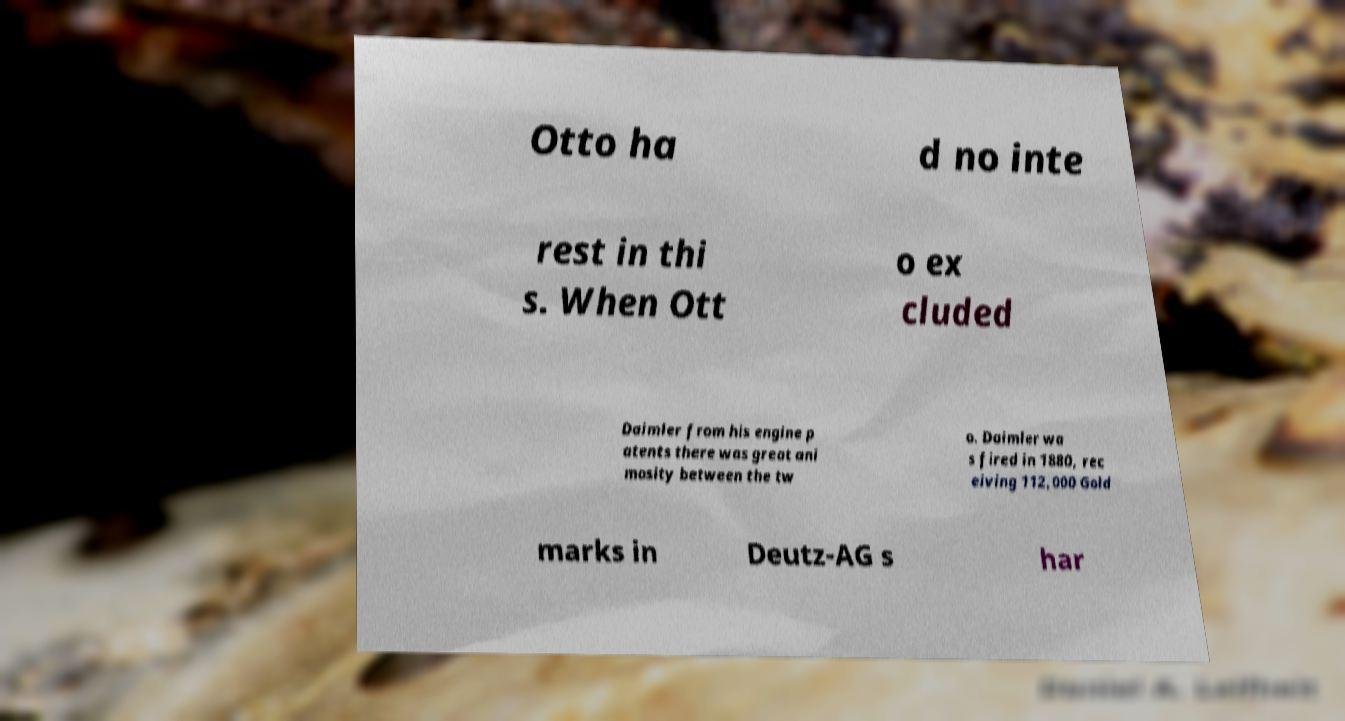Please identify and transcribe the text found in this image. Otto ha d no inte rest in thi s. When Ott o ex cluded Daimler from his engine p atents there was great ani mosity between the tw o. Daimler wa s fired in 1880, rec eiving 112,000 Gold marks in Deutz-AG s har 